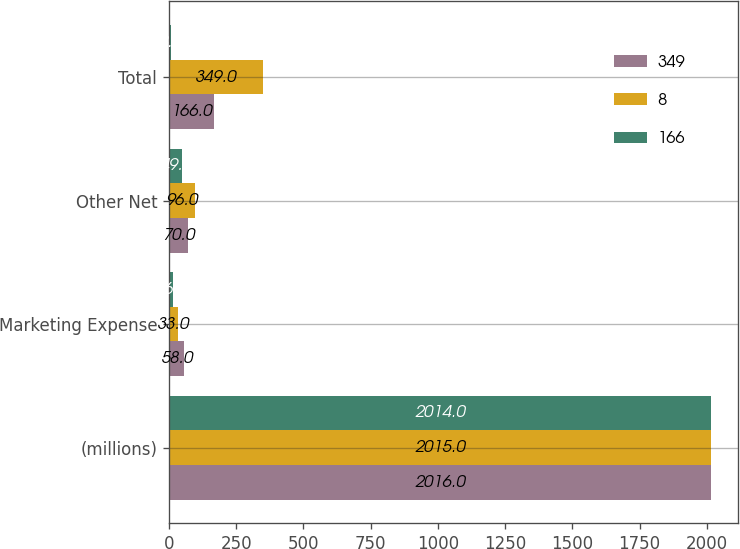<chart> <loc_0><loc_0><loc_500><loc_500><stacked_bar_chart><ecel><fcel>(millions)<fcel>Marketing Expense<fcel>Other Net<fcel>Total<nl><fcel>349<fcel>2016<fcel>58<fcel>70<fcel>166<nl><fcel>8<fcel>2015<fcel>33<fcel>96<fcel>349<nl><fcel>166<fcel>2014<fcel>16<fcel>49<fcel>8<nl></chart> 